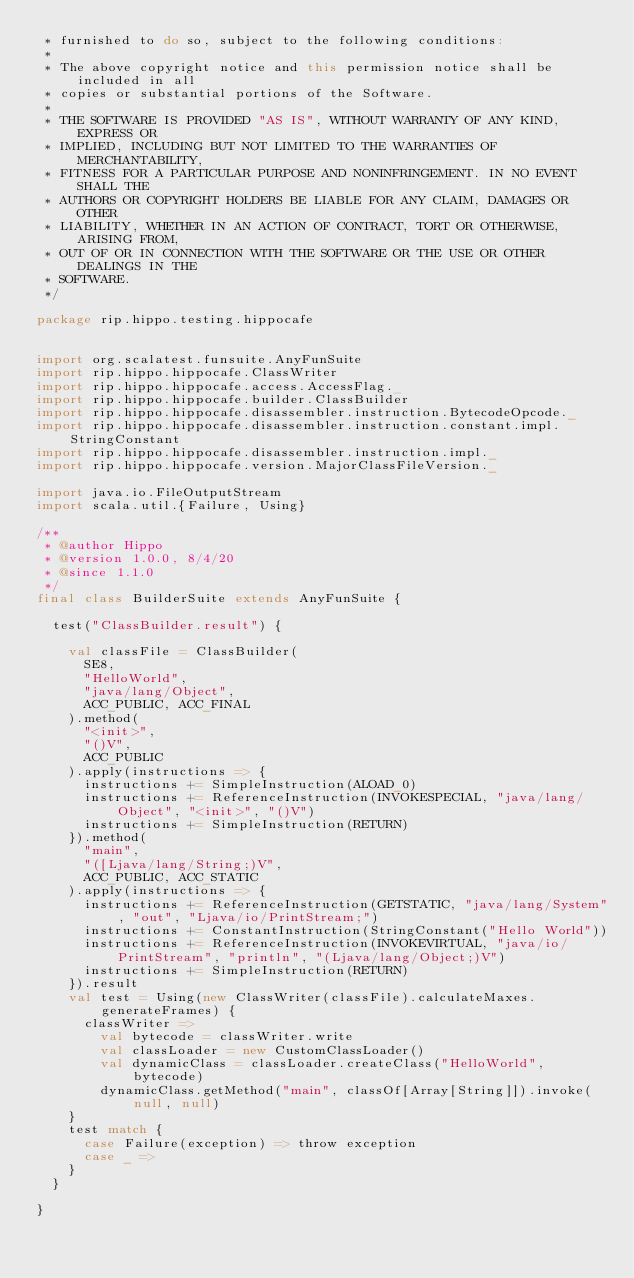<code> <loc_0><loc_0><loc_500><loc_500><_Scala_> * furnished to do so, subject to the following conditions:
 *
 * The above copyright notice and this permission notice shall be included in all
 * copies or substantial portions of the Software.
 *
 * THE SOFTWARE IS PROVIDED "AS IS", WITHOUT WARRANTY OF ANY KIND, EXPRESS OR
 * IMPLIED, INCLUDING BUT NOT LIMITED TO THE WARRANTIES OF MERCHANTABILITY,
 * FITNESS FOR A PARTICULAR PURPOSE AND NONINFRINGEMENT. IN NO EVENT SHALL THE
 * AUTHORS OR COPYRIGHT HOLDERS BE LIABLE FOR ANY CLAIM, DAMAGES OR OTHER
 * LIABILITY, WHETHER IN AN ACTION OF CONTRACT, TORT OR OTHERWISE, ARISING FROM,
 * OUT OF OR IN CONNECTION WITH THE SOFTWARE OR THE USE OR OTHER DEALINGS IN THE
 * SOFTWARE.
 */

package rip.hippo.testing.hippocafe


import org.scalatest.funsuite.AnyFunSuite
import rip.hippo.hippocafe.ClassWriter
import rip.hippo.hippocafe.access.AccessFlag._
import rip.hippo.hippocafe.builder.ClassBuilder
import rip.hippo.hippocafe.disassembler.instruction.BytecodeOpcode._
import rip.hippo.hippocafe.disassembler.instruction.constant.impl.StringConstant
import rip.hippo.hippocafe.disassembler.instruction.impl._
import rip.hippo.hippocafe.version.MajorClassFileVersion._

import java.io.FileOutputStream
import scala.util.{Failure, Using}

/**
 * @author Hippo
 * @version 1.0.0, 8/4/20
 * @since 1.1.0
 */
final class BuilderSuite extends AnyFunSuite {

  test("ClassBuilder.result") {

    val classFile = ClassBuilder(
      SE8,
      "HelloWorld",
      "java/lang/Object",
      ACC_PUBLIC, ACC_FINAL
    ).method(
      "<init>",
      "()V",
      ACC_PUBLIC
    ).apply(instructions => {
      instructions += SimpleInstruction(ALOAD_0)
      instructions += ReferenceInstruction(INVOKESPECIAL, "java/lang/Object", "<init>", "()V")
      instructions += SimpleInstruction(RETURN)
    }).method(
      "main",
      "([Ljava/lang/String;)V",
      ACC_PUBLIC, ACC_STATIC
    ).apply(instructions => {
      instructions += ReferenceInstruction(GETSTATIC, "java/lang/System", "out", "Ljava/io/PrintStream;")
      instructions += ConstantInstruction(StringConstant("Hello World"))
      instructions += ReferenceInstruction(INVOKEVIRTUAL, "java/io/PrintStream", "println", "(Ljava/lang/Object;)V")
      instructions += SimpleInstruction(RETURN)
    }).result
    val test = Using(new ClassWriter(classFile).calculateMaxes.generateFrames) {
      classWriter =>
        val bytecode = classWriter.write
        val classLoader = new CustomClassLoader()
        val dynamicClass = classLoader.createClass("HelloWorld", bytecode)
        dynamicClass.getMethod("main", classOf[Array[String]]).invoke(null, null)
    }
    test match {
      case Failure(exception) => throw exception
      case _ =>
    }
  }

}
</code> 